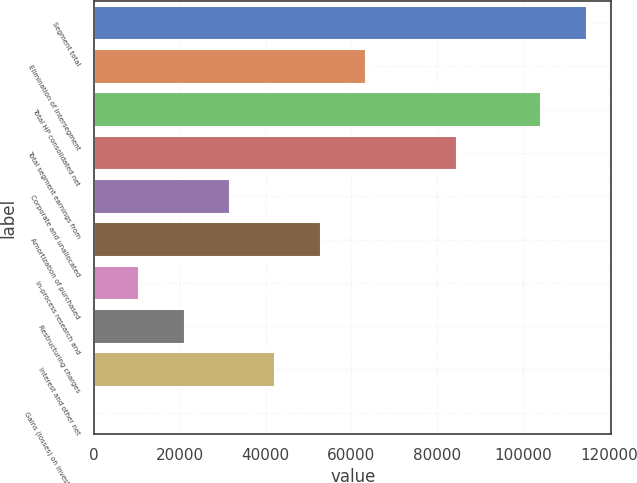Convert chart. <chart><loc_0><loc_0><loc_500><loc_500><bar_chart><fcel>Segment total<fcel>Elimination of intersegment<fcel>Total HP consolidated net<fcel>Total segment earnings from<fcel>Corporate and unallocated<fcel>Amortization of purchased<fcel>In-process research and<fcel>Restructuring charges<fcel>Interest and other net<fcel>Gains (losses) on investments<nl><fcel>114856<fcel>63432.8<fcel>104286<fcel>84572.4<fcel>31723.4<fcel>52863<fcel>10583.8<fcel>21153.6<fcel>42293.2<fcel>14<nl></chart> 